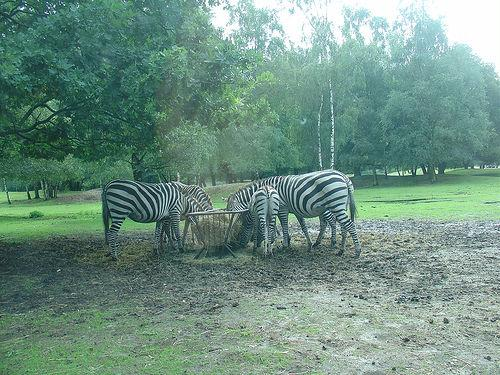Point out the chief subject and their activity in the scene. The chief subject is zebras who are busy eating hay from a trough. Summarize the primary subject's appearance and their activity in the image. Several striped zebras are gathered around a trough, enjoying a meal of hay. Describe the central theme and activity present in the image. The central theme revolves around zebras engaged in feeding on hay from a trough. Can you give a short overview of the most important elements and activities in the image? Zebras are gathered around a trough feeding on hay, with green trees and patchy grass in the background. Mention the primary focus of the image along with their current action. The main focus is on the zebras which are eating hay from a trough. Elaborate on the principal object and its activity in the image. The principal object in the image is a group of zebras which are consuming hay from a trough. Briefly explain the focal point of the image and its current action. The focal point of the image is zebras that are presently eating hay from a trough. What's the main subject and their present action in the picture? Zebras are the main subject, and they're eating hay from a trough. Provide a brief description of the primary subject and their action in the image. A group of zebras is eating hay from a trough surrounded by trees and grass. In a few words, describe the central subject and their ongoing activity in the image. Zebras feeding on hay from a trough in a grassy area. 